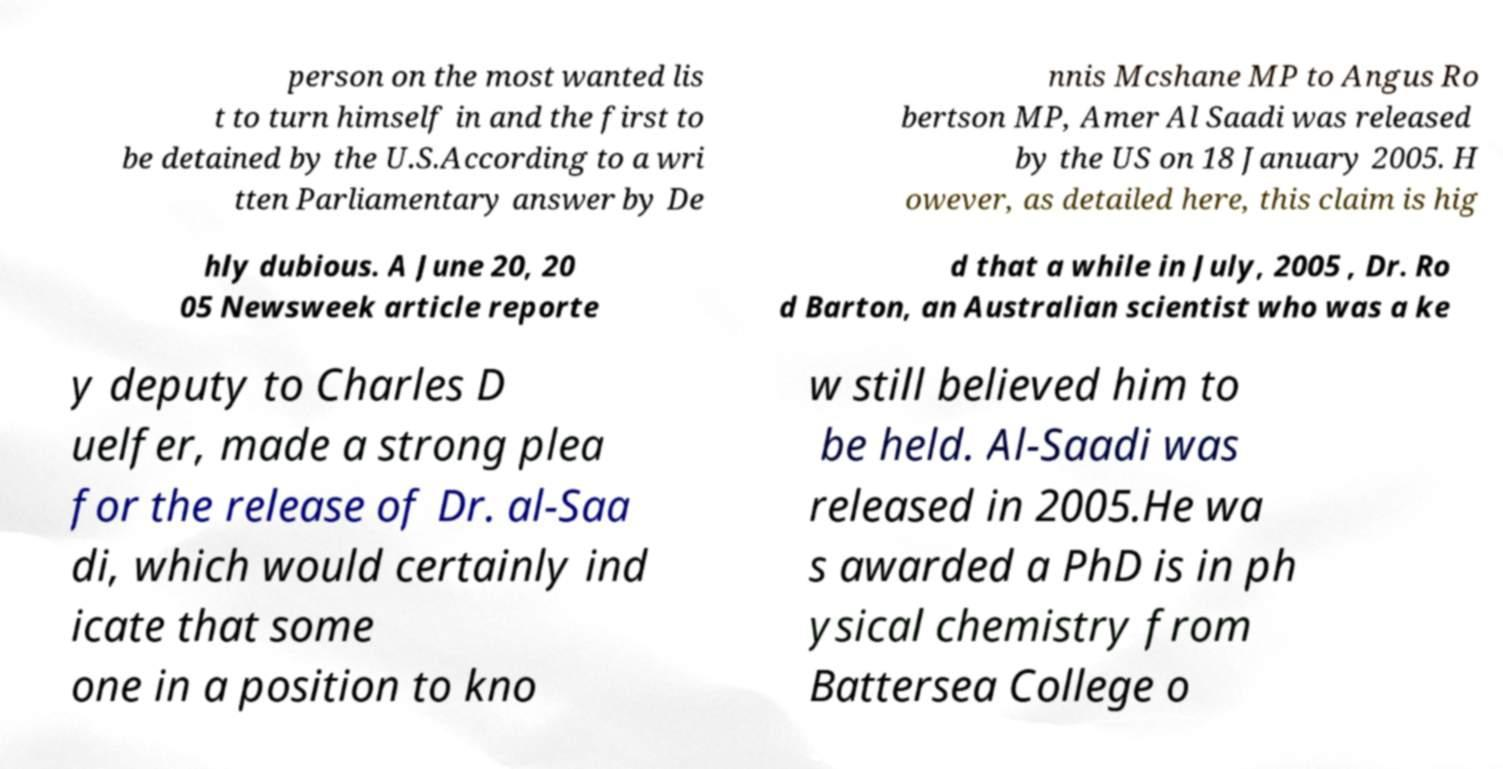I need the written content from this picture converted into text. Can you do that? person on the most wanted lis t to turn himself in and the first to be detained by the U.S.According to a wri tten Parliamentary answer by De nnis Mcshane MP to Angus Ro bertson MP, Amer Al Saadi was released by the US on 18 January 2005. H owever, as detailed here, this claim is hig hly dubious. A June 20, 20 05 Newsweek article reporte d that a while in July, 2005 , Dr. Ro d Barton, an Australian scientist who was a ke y deputy to Charles D uelfer, made a strong plea for the release of Dr. al-Saa di, which would certainly ind icate that some one in a position to kno w still believed him to be held. Al-Saadi was released in 2005.He wa s awarded a PhD is in ph ysical chemistry from Battersea College o 